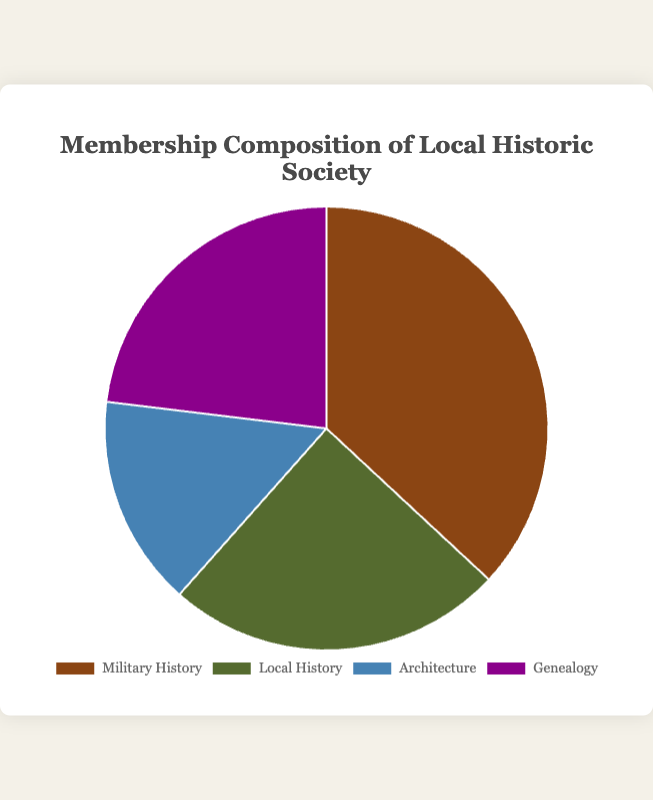What's the total number of members in the Local Historic Society? Sum the number of members in all interest areas: Military History (120) + Local History (80) + Architecture (50) + Genealogy (75) equals to 325 members.
Answer: 325 Which interest area has the highest number of members? Compare the number of members in each interest area: Military History (120), Local History (80), Architecture (50), and Genealogy (75). Military History has the highest number.
Answer: Military History Which interest area has the fewest members? Compare the number of members in each interest area: Military History (120), Local History (80), Architecture (50), and Genealogy (75). Architecture has the fewest members.
Answer: Architecture How many more members does Military History have compared to Genealogy? Subtract the number of members interested in Genealogy (75) from the number of members interested in Military History (120): 120 - 75 = 45.
Answer: 45 What's the percentage of members interested in Architecture? Calculate the percentage of total members (325) who are interested in Architecture (50): (50/325) * 100 ≈ 15.38%.
Answer: 15.38% What is the combined membership of Military History and Local History? Add the number of members interested in Military History (120) and Local History (80): 120 + 80 = 200.
Answer: 200 By how many members does Local History surpass Architecture? Subtract the number of members interested in Architecture (50) from Local History (80): 80 - 50 = 30.
Answer: 30 What is the ratio of members interested in Genealogy versus Military History? Divide the number of members interested in Genealogy (75) by the number of members interested in Military History (120): 75/120 = 0.625.
Answer: 0.625 Which interest area has the second highest number of members? Compare the number of members in each interest area and identify the one with the second highest number: Military History (120), Local History (80), Architecture (50), and Genealogy (75). Local History has the second highest.
Answer: Local History What is the combined percentage of members interested in Local History and Genealogy? Calculate the percentage of total members for Local History (80) and Genealogy (75) and sum them: (80/325) * 100 ≈ 24.62% + (75/325) * 100 ≈ 23.08% equals to approximately 47.7%.
Answer: 47.7% 